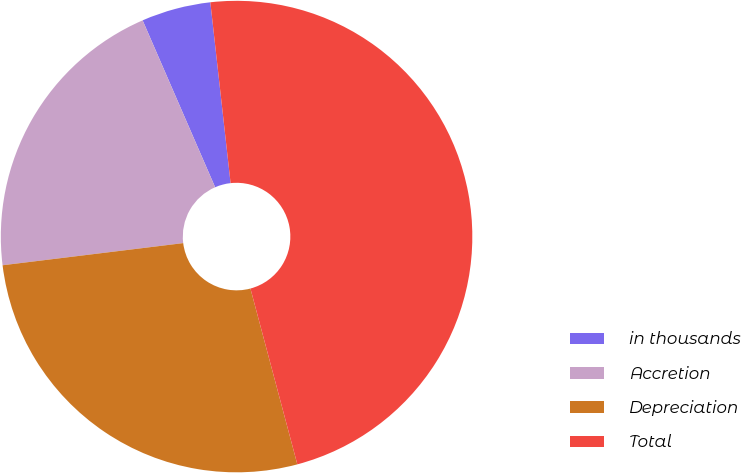<chart> <loc_0><loc_0><loc_500><loc_500><pie_chart><fcel>in thousands<fcel>Accretion<fcel>Depreciation<fcel>Total<nl><fcel>4.75%<fcel>20.42%<fcel>27.21%<fcel>47.63%<nl></chart> 